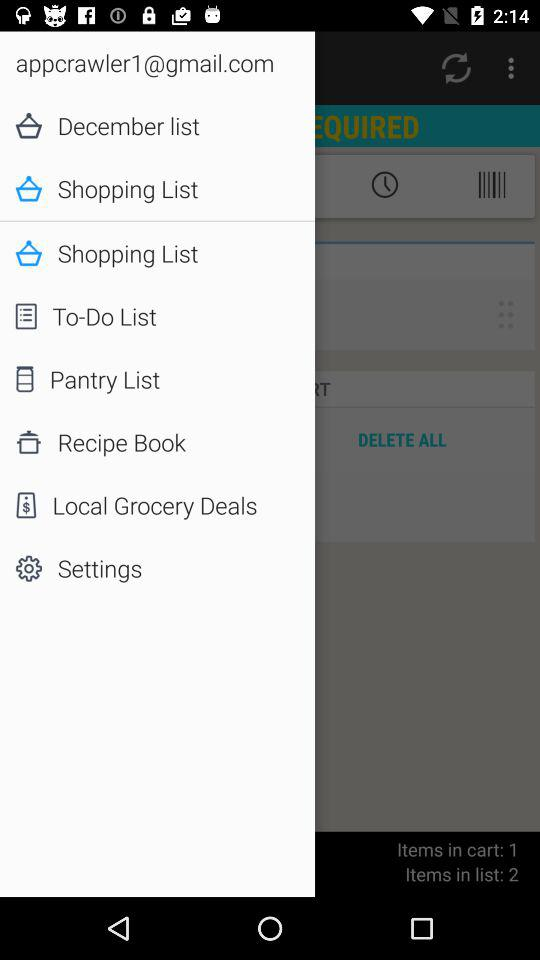What is the count of items in the list? The count of items in the list is 2. 